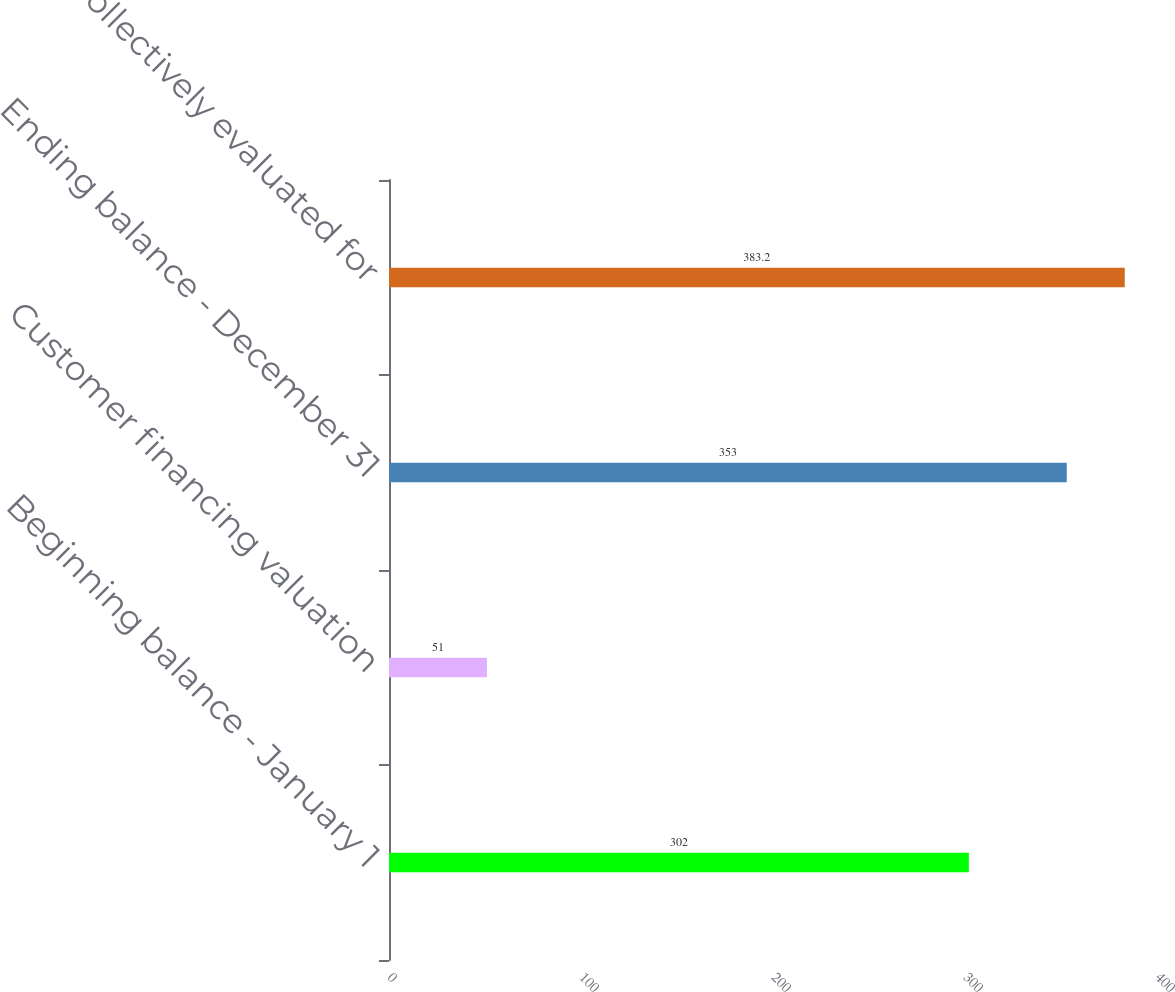Convert chart. <chart><loc_0><loc_0><loc_500><loc_500><bar_chart><fcel>Beginning balance - January 1<fcel>Customer financing valuation<fcel>Ending balance - December 31<fcel>Collectively evaluated for<nl><fcel>302<fcel>51<fcel>353<fcel>383.2<nl></chart> 